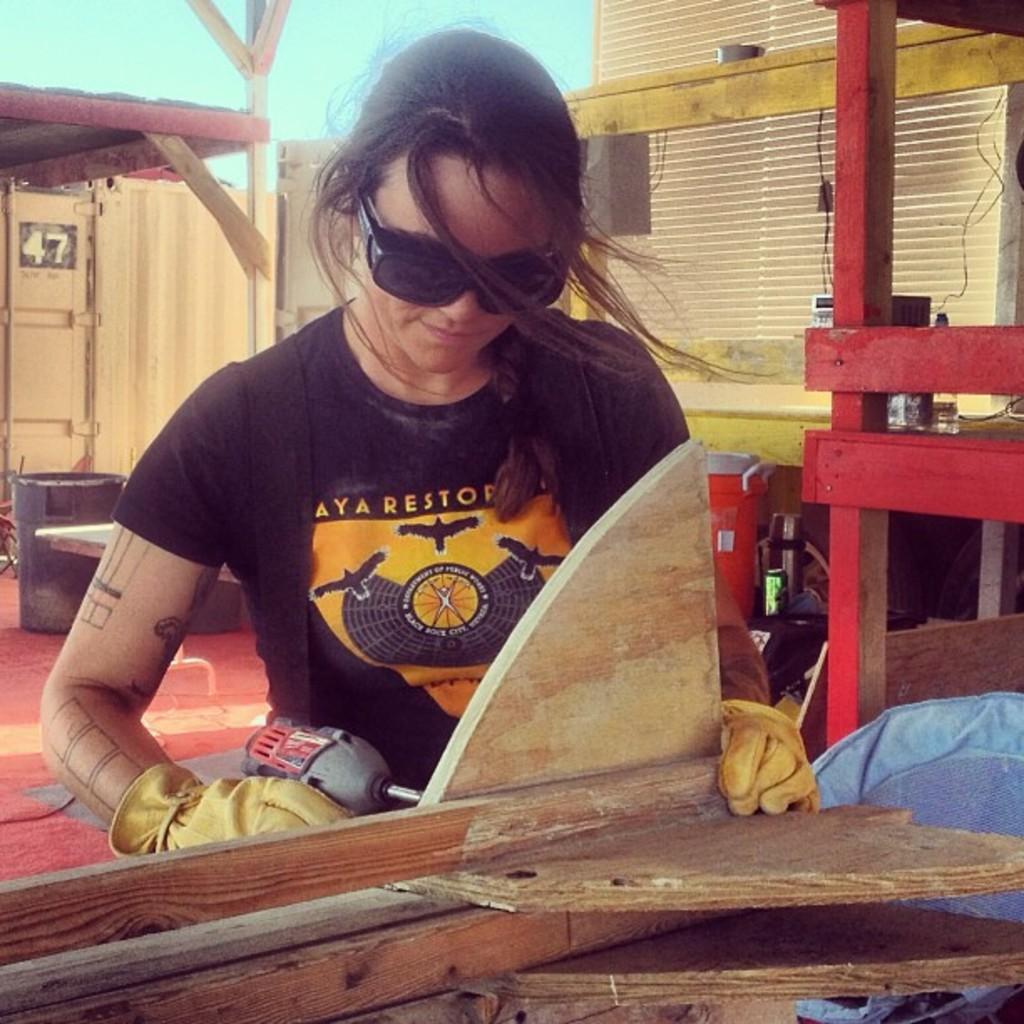Describe this image in one or two sentences. This image consists of a woman wearing black T-shirt. She is holding a drilling machine. In front of her there is wood. In the background, there are cabins made up of wood. At the bottom, there is a floor. 